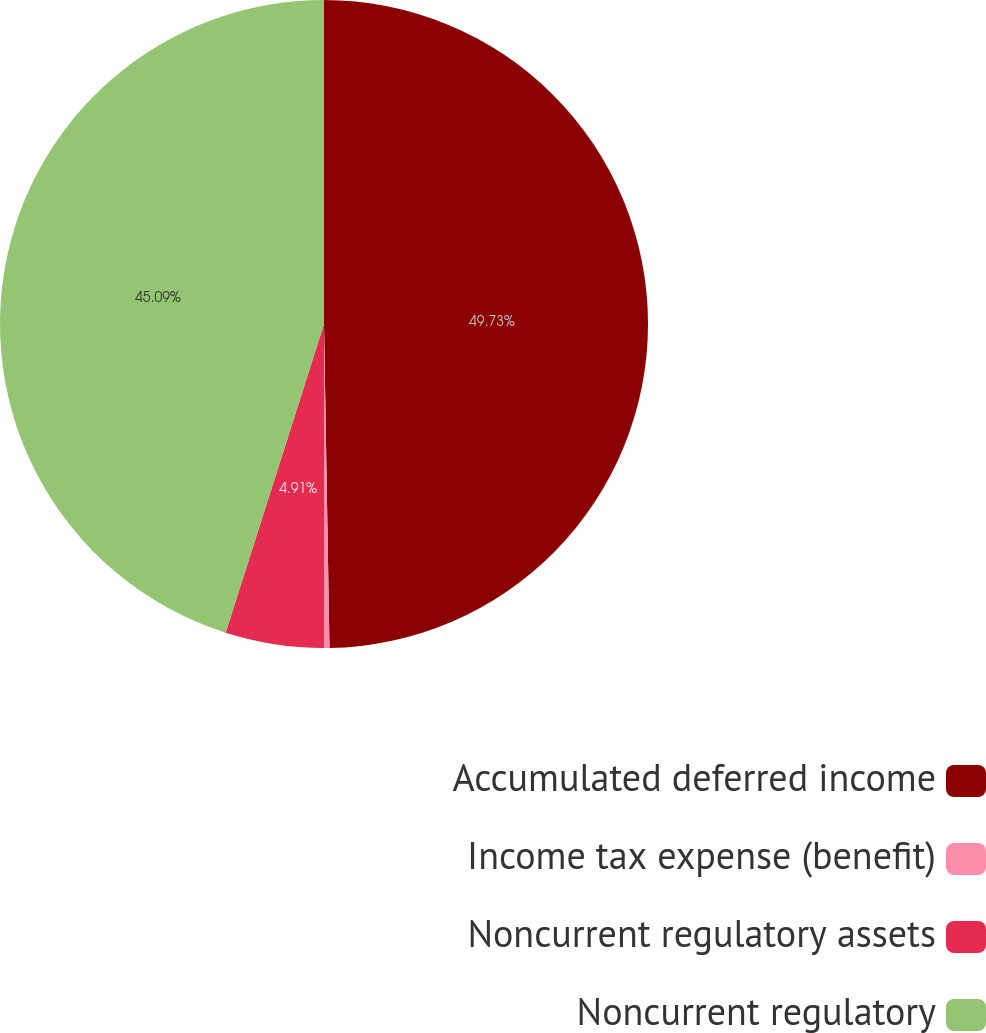Convert chart to OTSL. <chart><loc_0><loc_0><loc_500><loc_500><pie_chart><fcel>Accumulated deferred income<fcel>Income tax expense (benefit)<fcel>Noncurrent regulatory assets<fcel>Noncurrent regulatory<nl><fcel>49.73%<fcel>0.27%<fcel>4.91%<fcel>45.09%<nl></chart> 